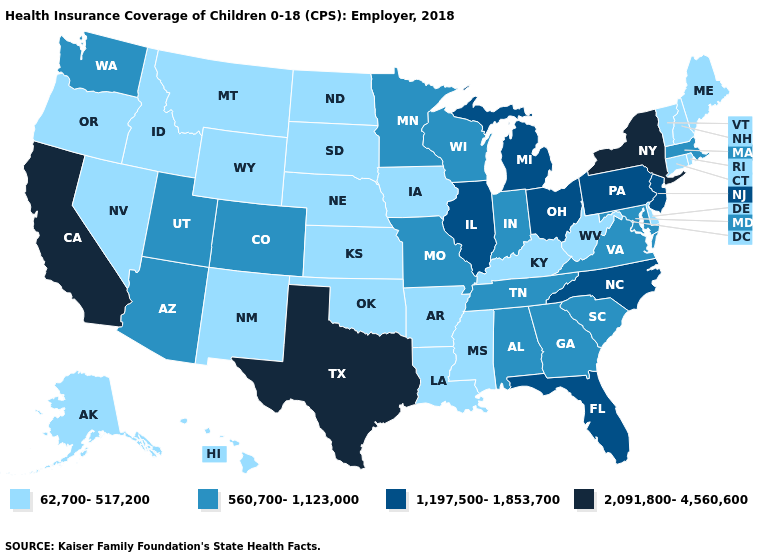Name the states that have a value in the range 2,091,800-4,560,600?
Quick response, please. California, New York, Texas. What is the highest value in the USA?
Be succinct. 2,091,800-4,560,600. Does the map have missing data?
Quick response, please. No. Does the map have missing data?
Concise answer only. No. Does Oregon have a lower value than Illinois?
Write a very short answer. Yes. What is the value of New Mexico?
Keep it brief. 62,700-517,200. Name the states that have a value in the range 1,197,500-1,853,700?
Write a very short answer. Florida, Illinois, Michigan, New Jersey, North Carolina, Ohio, Pennsylvania. Name the states that have a value in the range 62,700-517,200?
Short answer required. Alaska, Arkansas, Connecticut, Delaware, Hawaii, Idaho, Iowa, Kansas, Kentucky, Louisiana, Maine, Mississippi, Montana, Nebraska, Nevada, New Hampshire, New Mexico, North Dakota, Oklahoma, Oregon, Rhode Island, South Dakota, Vermont, West Virginia, Wyoming. Does Colorado have a higher value than Oklahoma?
Be succinct. Yes. Does the first symbol in the legend represent the smallest category?
Write a very short answer. Yes. Does the first symbol in the legend represent the smallest category?
Keep it brief. Yes. Does the first symbol in the legend represent the smallest category?
Quick response, please. Yes. Among the states that border California , does Oregon have the highest value?
Give a very brief answer. No. Among the states that border Connecticut , does New York have the highest value?
Write a very short answer. Yes. What is the value of South Dakota?
Write a very short answer. 62,700-517,200. 